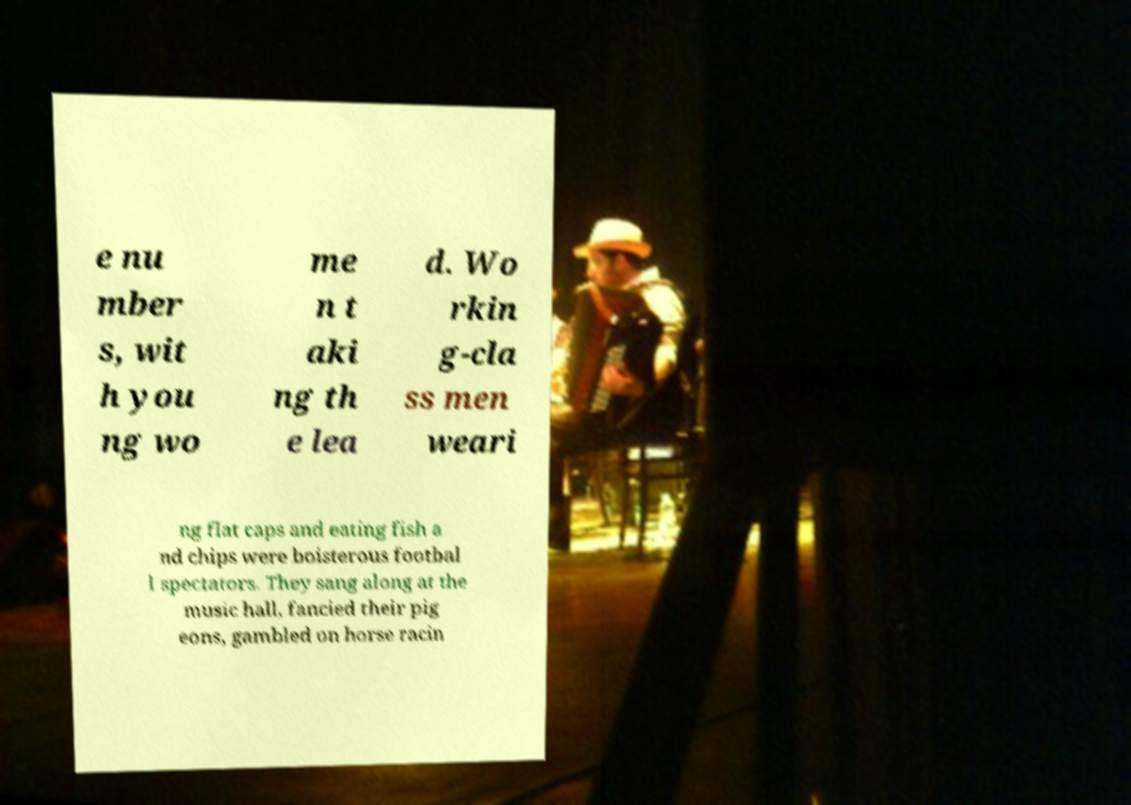Can you read and provide the text displayed in the image?This photo seems to have some interesting text. Can you extract and type it out for me? e nu mber s, wit h you ng wo me n t aki ng th e lea d. Wo rkin g-cla ss men weari ng flat caps and eating fish a nd chips were boisterous footbal l spectators. They sang along at the music hall, fancied their pig eons, gambled on horse racin 